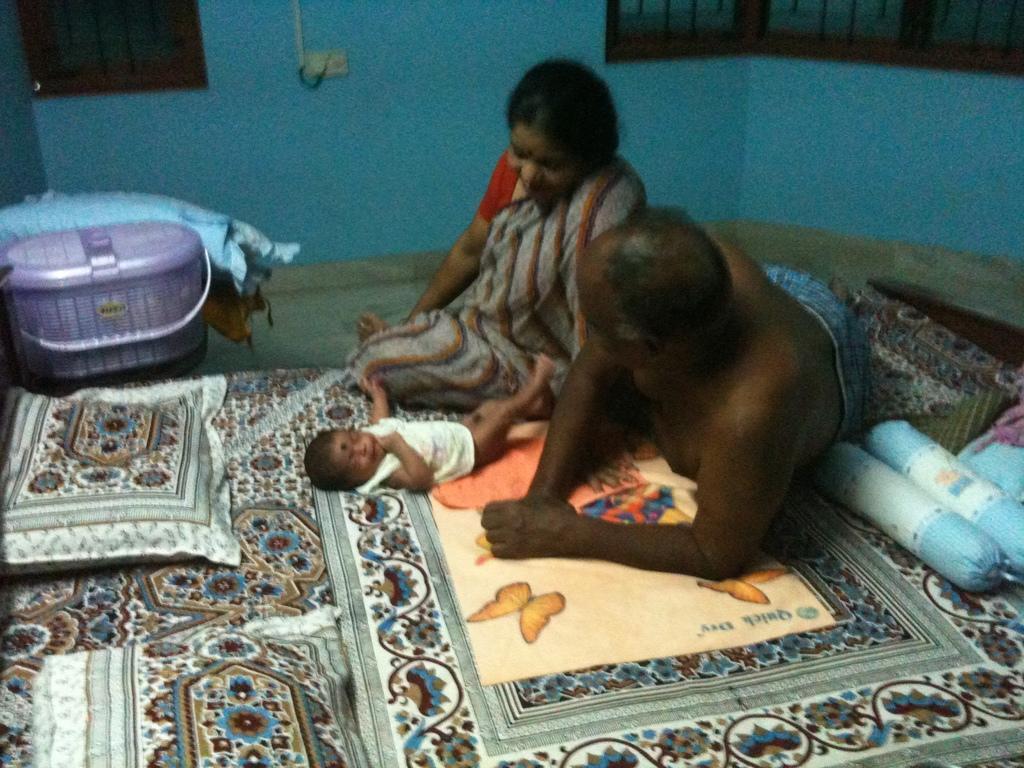In one or two sentences, can you explain what this image depicts? In the image there is a baby and two people on the bed and on the right side there are two pillows, beside the bed there is a basket and other clothes. In the background there is a wall and beside the wall there are windows. 